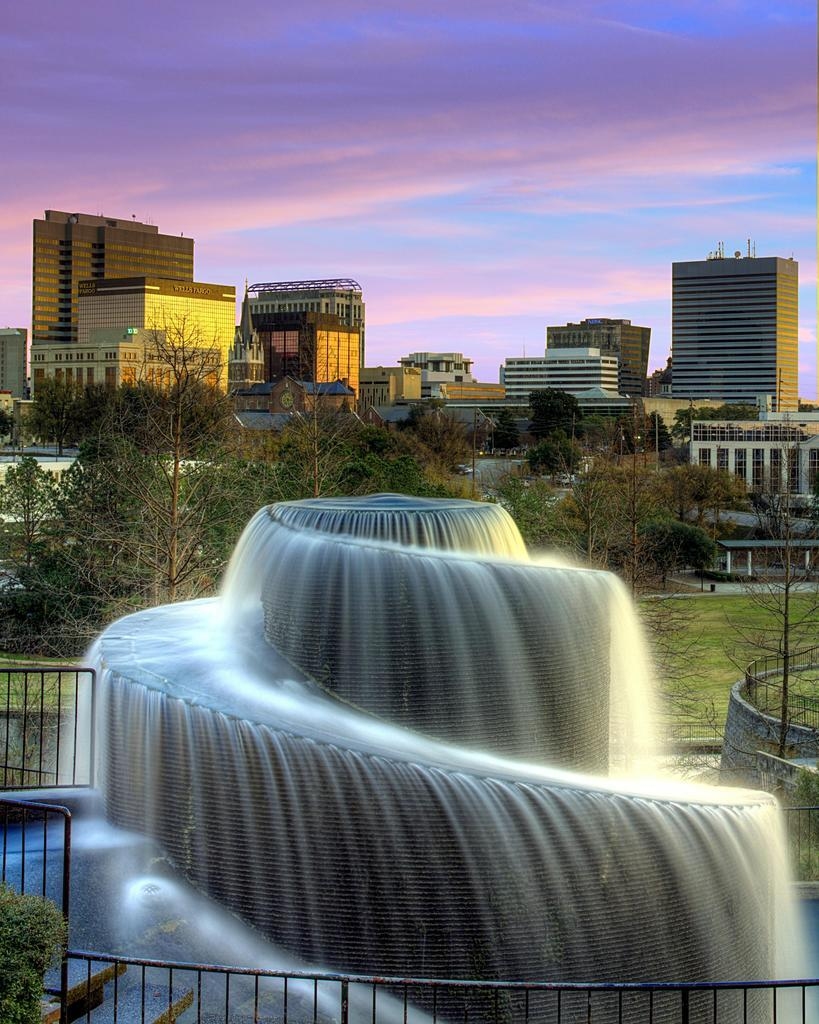What is the main feature of the image? There is a spiral fountain of water in the image. What surrounds the fountain? The fountain is surrounded by gates. What type of vegetation is present in the image? Grass and trees are visible in the image. What structures can be seen in the image? There are buildings in the image. What is the color of the sky in the image? The sky appears to be purple in the image. Are there any fairies attacking the fountain in the image? There are no fairies or attacks present in the image; it features a spiral fountain of water surrounded by gates. Can you see a pin holding the fountain together in the image? There is no pin visible in the image; the fountain is a continuous stream of water. 